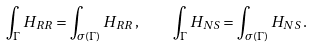Convert formula to latex. <formula><loc_0><loc_0><loc_500><loc_500>\int _ { \Gamma } H _ { R R } = \int _ { \sigma ( \Gamma ) } H _ { R R } \, , \quad \int _ { \Gamma } H _ { N S } = \int _ { \sigma ( \Gamma ) } H _ { N S } \, .</formula> 